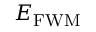Convert formula to latex. <formula><loc_0><loc_0><loc_500><loc_500>E _ { F W M }</formula> 